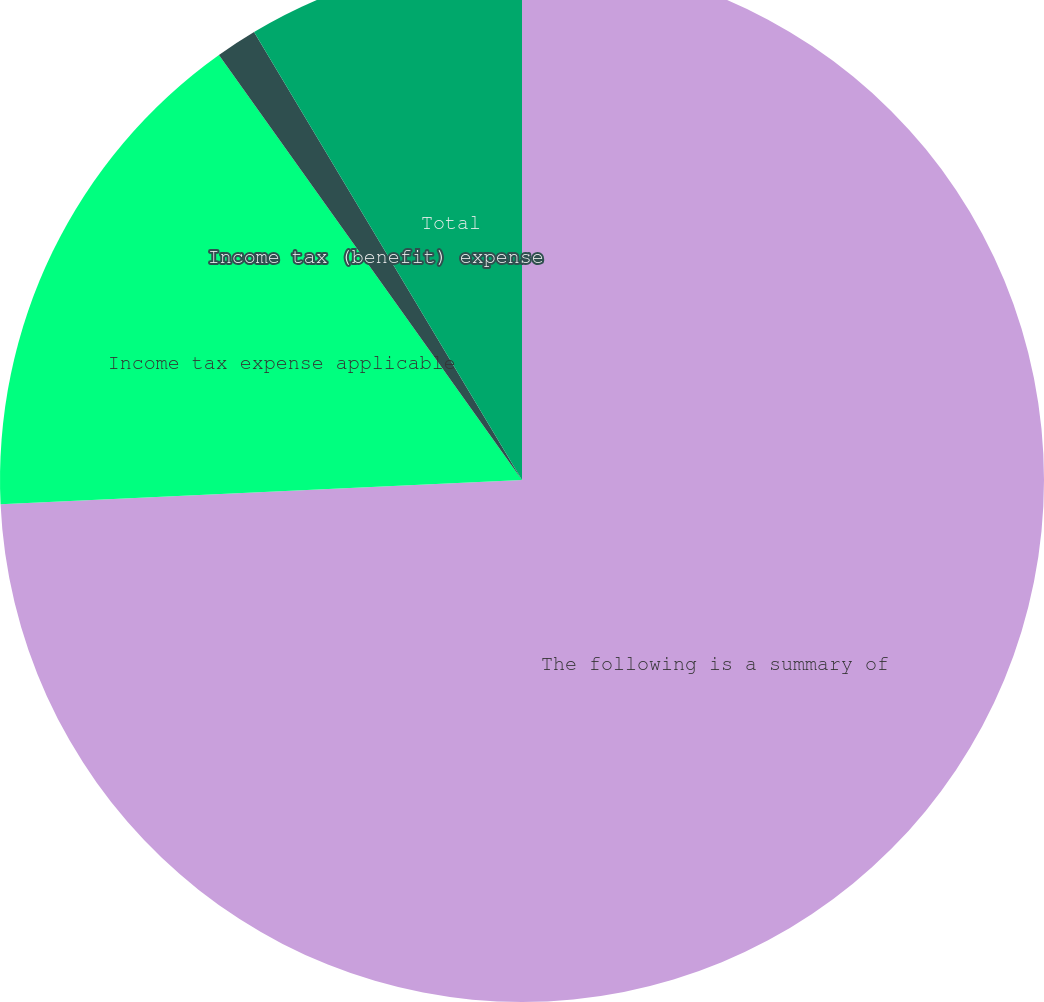<chart> <loc_0><loc_0><loc_500><loc_500><pie_chart><fcel>The following is a summary of<fcel>Income tax expense applicable<fcel>Income tax (benefit) expense<fcel>Total<nl><fcel>74.27%<fcel>15.88%<fcel>1.28%<fcel>8.58%<nl></chart> 